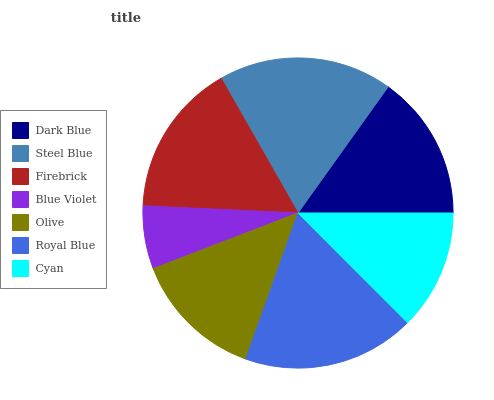Is Blue Violet the minimum?
Answer yes or no. Yes. Is Steel Blue the maximum?
Answer yes or no. Yes. Is Firebrick the minimum?
Answer yes or no. No. Is Firebrick the maximum?
Answer yes or no. No. Is Steel Blue greater than Firebrick?
Answer yes or no. Yes. Is Firebrick less than Steel Blue?
Answer yes or no. Yes. Is Firebrick greater than Steel Blue?
Answer yes or no. No. Is Steel Blue less than Firebrick?
Answer yes or no. No. Is Dark Blue the high median?
Answer yes or no. Yes. Is Dark Blue the low median?
Answer yes or no. Yes. Is Firebrick the high median?
Answer yes or no. No. Is Royal Blue the low median?
Answer yes or no. No. 